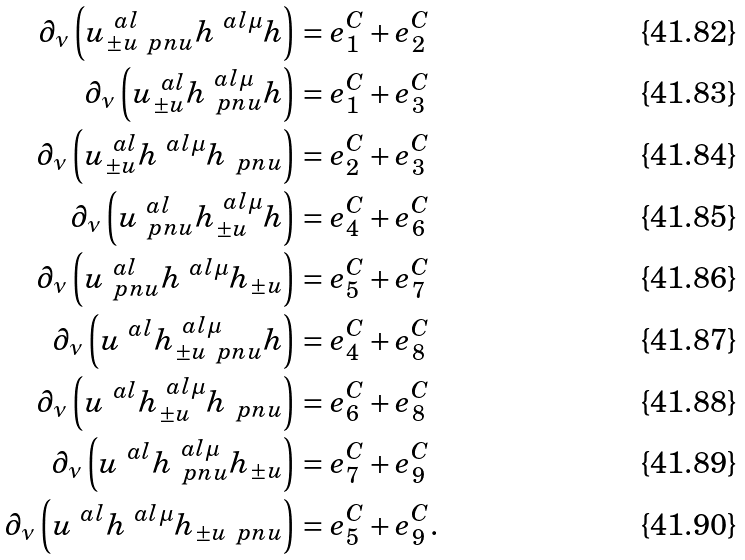Convert formula to latex. <formula><loc_0><loc_0><loc_500><loc_500>\partial _ { \nu } \left ( u ^ { \ a l } _ { \pm u \ p n u } h ^ { \ a l \mu } h \right ) & = e ^ { C } _ { 1 } + e ^ { C } _ { 2 } \\ \partial _ { \nu } \left ( u ^ { \ a l } _ { \pm u } h ^ { \ a l \mu } _ { \ p n u } h \right ) & = e ^ { C } _ { 1 } + e ^ { C } _ { 3 } \\ \partial _ { \nu } \left ( u ^ { \ a l } _ { \pm u } h ^ { \ a l \mu } h _ { \ p n u } \right ) & = e ^ { C } _ { 2 } + e ^ { C } _ { 3 } \\ \partial _ { \nu } \left ( u ^ { \ a l } _ { \ p n u } h ^ { \ a l \mu } _ { \pm u } h \right ) & = e ^ { C } _ { 4 } + e ^ { C } _ { 6 } \\ \partial _ { \nu } \left ( u ^ { \ a l } _ { \ p n u } h ^ { \ a l \mu } h _ { \pm u } \right ) & = e ^ { C } _ { 5 } + e ^ { C } _ { 7 } \\ \partial _ { \nu } \left ( u ^ { \ a l } h ^ { \ a l \mu } _ { \pm u \ p n u } h \right ) & = e ^ { C } _ { 4 } + e ^ { C } _ { 8 } \\ \partial _ { \nu } \left ( u ^ { \ a l } h ^ { \ a l \mu } _ { \pm u } h _ { \ p n u } \right ) & = e ^ { C } _ { 6 } + e ^ { C } _ { 8 } \\ \partial _ { \nu } \left ( u ^ { \ a l } h ^ { \ a l \mu } _ { \ p n u } h _ { \pm u } \right ) & = e ^ { C } _ { 7 } + e ^ { C } _ { 9 } \\ \partial _ { \nu } \left ( u ^ { \ a l } h ^ { \ a l \mu } h _ { \pm u \ p n u } \right ) & = e ^ { C } _ { 5 } + e ^ { C } _ { 9 } .</formula> 